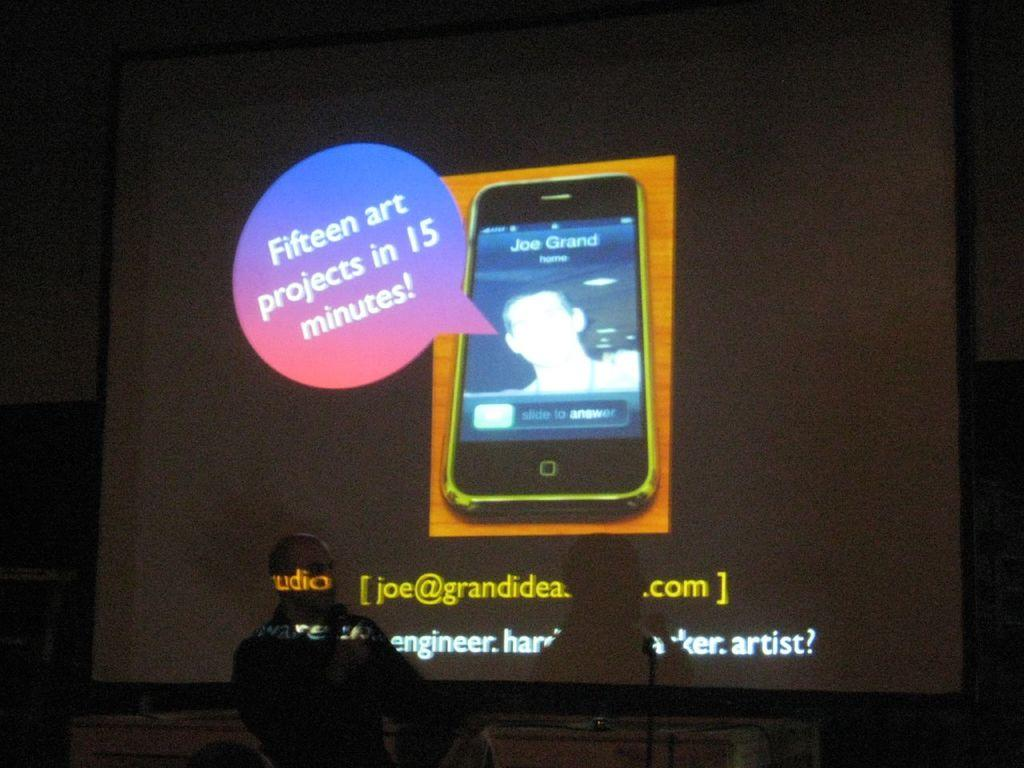Who or what is present in the image? There is a person in the image. What can be seen in the background or foreground of the image? There is a screen in the image. What is displayed on the screen? The screen displays a mobile phone. What is visible on the mobile phone's screen? The mobile phone has text on it. What type of plantation can be seen in the background of the image? There is no plantation present in the image; it features a person and a screen displaying a mobile phone. 